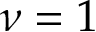<formula> <loc_0><loc_0><loc_500><loc_500>\nu = 1</formula> 